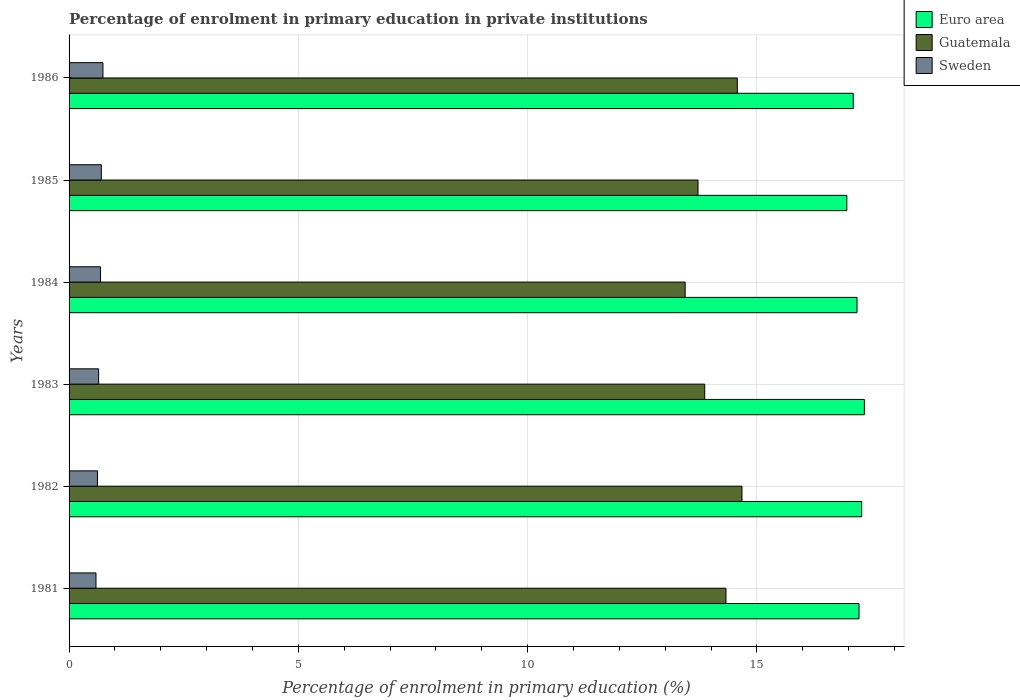How many different coloured bars are there?
Ensure brevity in your answer.  3. How many bars are there on the 2nd tick from the bottom?
Make the answer very short. 3. In how many cases, is the number of bars for a given year not equal to the number of legend labels?
Provide a succinct answer. 0. What is the percentage of enrolment in primary education in Euro area in 1986?
Your answer should be compact. 17.1. Across all years, what is the maximum percentage of enrolment in primary education in Euro area?
Offer a terse response. 17.34. Across all years, what is the minimum percentage of enrolment in primary education in Euro area?
Your answer should be very brief. 16.96. What is the total percentage of enrolment in primary education in Sweden in the graph?
Offer a very short reply. 3.98. What is the difference between the percentage of enrolment in primary education in Guatemala in 1981 and that in 1984?
Your answer should be compact. 0.89. What is the difference between the percentage of enrolment in primary education in Guatemala in 1985 and the percentage of enrolment in primary education in Sweden in 1986?
Provide a succinct answer. 12.98. What is the average percentage of enrolment in primary education in Sweden per year?
Your answer should be very brief. 0.66. In the year 1982, what is the difference between the percentage of enrolment in primary education in Euro area and percentage of enrolment in primary education in Sweden?
Offer a very short reply. 16.66. In how many years, is the percentage of enrolment in primary education in Guatemala greater than 5 %?
Keep it short and to the point. 6. What is the ratio of the percentage of enrolment in primary education in Euro area in 1982 to that in 1984?
Your answer should be compact. 1.01. Is the difference between the percentage of enrolment in primary education in Euro area in 1981 and 1986 greater than the difference between the percentage of enrolment in primary education in Sweden in 1981 and 1986?
Provide a short and direct response. Yes. What is the difference between the highest and the second highest percentage of enrolment in primary education in Sweden?
Give a very brief answer. 0.04. What is the difference between the highest and the lowest percentage of enrolment in primary education in Sweden?
Make the answer very short. 0.15. Is the sum of the percentage of enrolment in primary education in Euro area in 1983 and 1984 greater than the maximum percentage of enrolment in primary education in Sweden across all years?
Your response must be concise. Yes. What does the 3rd bar from the top in 1982 represents?
Your response must be concise. Euro area. What does the 2nd bar from the bottom in 1981 represents?
Give a very brief answer. Guatemala. Is it the case that in every year, the sum of the percentage of enrolment in primary education in Euro area and percentage of enrolment in primary education in Sweden is greater than the percentage of enrolment in primary education in Guatemala?
Give a very brief answer. Yes. How many bars are there?
Your answer should be very brief. 18. How many years are there in the graph?
Your answer should be very brief. 6. Does the graph contain any zero values?
Give a very brief answer. No. Does the graph contain grids?
Provide a short and direct response. Yes. How many legend labels are there?
Your answer should be very brief. 3. How are the legend labels stacked?
Keep it short and to the point. Vertical. What is the title of the graph?
Ensure brevity in your answer.  Percentage of enrolment in primary education in private institutions. What is the label or title of the X-axis?
Ensure brevity in your answer.  Percentage of enrolment in primary education (%). What is the label or title of the Y-axis?
Your answer should be very brief. Years. What is the Percentage of enrolment in primary education (%) in Euro area in 1981?
Make the answer very short. 17.22. What is the Percentage of enrolment in primary education (%) in Guatemala in 1981?
Your answer should be very brief. 14.32. What is the Percentage of enrolment in primary education (%) of Sweden in 1981?
Ensure brevity in your answer.  0.59. What is the Percentage of enrolment in primary education (%) in Euro area in 1982?
Give a very brief answer. 17.28. What is the Percentage of enrolment in primary education (%) in Guatemala in 1982?
Provide a short and direct response. 14.67. What is the Percentage of enrolment in primary education (%) of Sweden in 1982?
Offer a very short reply. 0.62. What is the Percentage of enrolment in primary education (%) of Euro area in 1983?
Your answer should be compact. 17.34. What is the Percentage of enrolment in primary education (%) of Guatemala in 1983?
Offer a very short reply. 13.86. What is the Percentage of enrolment in primary education (%) in Sweden in 1983?
Offer a very short reply. 0.64. What is the Percentage of enrolment in primary education (%) in Euro area in 1984?
Provide a short and direct response. 17.18. What is the Percentage of enrolment in primary education (%) of Guatemala in 1984?
Offer a very short reply. 13.43. What is the Percentage of enrolment in primary education (%) of Sweden in 1984?
Provide a short and direct response. 0.69. What is the Percentage of enrolment in primary education (%) in Euro area in 1985?
Keep it short and to the point. 16.96. What is the Percentage of enrolment in primary education (%) of Guatemala in 1985?
Provide a succinct answer. 13.71. What is the Percentage of enrolment in primary education (%) of Sweden in 1985?
Your response must be concise. 0.7. What is the Percentage of enrolment in primary education (%) of Euro area in 1986?
Offer a terse response. 17.1. What is the Percentage of enrolment in primary education (%) in Guatemala in 1986?
Offer a very short reply. 14.57. What is the Percentage of enrolment in primary education (%) of Sweden in 1986?
Ensure brevity in your answer.  0.74. Across all years, what is the maximum Percentage of enrolment in primary education (%) of Euro area?
Your answer should be very brief. 17.34. Across all years, what is the maximum Percentage of enrolment in primary education (%) in Guatemala?
Provide a succinct answer. 14.67. Across all years, what is the maximum Percentage of enrolment in primary education (%) in Sweden?
Your answer should be very brief. 0.74. Across all years, what is the minimum Percentage of enrolment in primary education (%) of Euro area?
Offer a terse response. 16.96. Across all years, what is the minimum Percentage of enrolment in primary education (%) in Guatemala?
Give a very brief answer. 13.43. Across all years, what is the minimum Percentage of enrolment in primary education (%) in Sweden?
Provide a succinct answer. 0.59. What is the total Percentage of enrolment in primary education (%) of Euro area in the graph?
Your response must be concise. 103.09. What is the total Percentage of enrolment in primary education (%) of Guatemala in the graph?
Your answer should be compact. 84.58. What is the total Percentage of enrolment in primary education (%) of Sweden in the graph?
Give a very brief answer. 3.98. What is the difference between the Percentage of enrolment in primary education (%) in Euro area in 1981 and that in 1982?
Make the answer very short. -0.06. What is the difference between the Percentage of enrolment in primary education (%) of Guatemala in 1981 and that in 1982?
Your response must be concise. -0.35. What is the difference between the Percentage of enrolment in primary education (%) in Sweden in 1981 and that in 1982?
Provide a succinct answer. -0.03. What is the difference between the Percentage of enrolment in primary education (%) of Euro area in 1981 and that in 1983?
Give a very brief answer. -0.12. What is the difference between the Percentage of enrolment in primary education (%) of Guatemala in 1981 and that in 1983?
Provide a succinct answer. 0.46. What is the difference between the Percentage of enrolment in primary education (%) of Sweden in 1981 and that in 1983?
Your answer should be compact. -0.06. What is the difference between the Percentage of enrolment in primary education (%) in Euro area in 1981 and that in 1984?
Ensure brevity in your answer.  0.04. What is the difference between the Percentage of enrolment in primary education (%) in Guatemala in 1981 and that in 1984?
Offer a very short reply. 0.89. What is the difference between the Percentage of enrolment in primary education (%) of Sweden in 1981 and that in 1984?
Your answer should be very brief. -0.1. What is the difference between the Percentage of enrolment in primary education (%) of Euro area in 1981 and that in 1985?
Ensure brevity in your answer.  0.27. What is the difference between the Percentage of enrolment in primary education (%) of Guatemala in 1981 and that in 1985?
Your response must be concise. 0.61. What is the difference between the Percentage of enrolment in primary education (%) of Sweden in 1981 and that in 1985?
Give a very brief answer. -0.12. What is the difference between the Percentage of enrolment in primary education (%) in Euro area in 1981 and that in 1986?
Make the answer very short. 0.13. What is the difference between the Percentage of enrolment in primary education (%) of Guatemala in 1981 and that in 1986?
Keep it short and to the point. -0.25. What is the difference between the Percentage of enrolment in primary education (%) of Sweden in 1981 and that in 1986?
Your response must be concise. -0.15. What is the difference between the Percentage of enrolment in primary education (%) of Euro area in 1982 and that in 1983?
Provide a succinct answer. -0.06. What is the difference between the Percentage of enrolment in primary education (%) in Guatemala in 1982 and that in 1983?
Offer a terse response. 0.81. What is the difference between the Percentage of enrolment in primary education (%) in Sweden in 1982 and that in 1983?
Give a very brief answer. -0.03. What is the difference between the Percentage of enrolment in primary education (%) in Euro area in 1982 and that in 1984?
Make the answer very short. 0.1. What is the difference between the Percentage of enrolment in primary education (%) in Guatemala in 1982 and that in 1984?
Your answer should be compact. 1.24. What is the difference between the Percentage of enrolment in primary education (%) in Sweden in 1982 and that in 1984?
Give a very brief answer. -0.07. What is the difference between the Percentage of enrolment in primary education (%) in Euro area in 1982 and that in 1985?
Provide a succinct answer. 0.32. What is the difference between the Percentage of enrolment in primary education (%) in Guatemala in 1982 and that in 1985?
Offer a terse response. 0.96. What is the difference between the Percentage of enrolment in primary education (%) of Sweden in 1982 and that in 1985?
Your response must be concise. -0.08. What is the difference between the Percentage of enrolment in primary education (%) in Euro area in 1982 and that in 1986?
Offer a terse response. 0.18. What is the difference between the Percentage of enrolment in primary education (%) of Guatemala in 1982 and that in 1986?
Offer a very short reply. 0.1. What is the difference between the Percentage of enrolment in primary education (%) in Sweden in 1982 and that in 1986?
Offer a terse response. -0.12. What is the difference between the Percentage of enrolment in primary education (%) of Euro area in 1983 and that in 1984?
Make the answer very short. 0.16. What is the difference between the Percentage of enrolment in primary education (%) of Guatemala in 1983 and that in 1984?
Offer a very short reply. 0.43. What is the difference between the Percentage of enrolment in primary education (%) in Sweden in 1983 and that in 1984?
Your response must be concise. -0.04. What is the difference between the Percentage of enrolment in primary education (%) of Euro area in 1983 and that in 1985?
Offer a very short reply. 0.38. What is the difference between the Percentage of enrolment in primary education (%) of Guatemala in 1983 and that in 1985?
Offer a very short reply. 0.15. What is the difference between the Percentage of enrolment in primary education (%) in Sweden in 1983 and that in 1985?
Your answer should be compact. -0.06. What is the difference between the Percentage of enrolment in primary education (%) in Euro area in 1983 and that in 1986?
Provide a short and direct response. 0.24. What is the difference between the Percentage of enrolment in primary education (%) in Guatemala in 1983 and that in 1986?
Ensure brevity in your answer.  -0.71. What is the difference between the Percentage of enrolment in primary education (%) in Sweden in 1983 and that in 1986?
Your response must be concise. -0.09. What is the difference between the Percentage of enrolment in primary education (%) of Euro area in 1984 and that in 1985?
Your response must be concise. 0.22. What is the difference between the Percentage of enrolment in primary education (%) of Guatemala in 1984 and that in 1985?
Offer a terse response. -0.28. What is the difference between the Percentage of enrolment in primary education (%) of Sweden in 1984 and that in 1985?
Keep it short and to the point. -0.02. What is the difference between the Percentage of enrolment in primary education (%) in Euro area in 1984 and that in 1986?
Ensure brevity in your answer.  0.08. What is the difference between the Percentage of enrolment in primary education (%) in Guatemala in 1984 and that in 1986?
Provide a short and direct response. -1.14. What is the difference between the Percentage of enrolment in primary education (%) in Sweden in 1984 and that in 1986?
Your answer should be compact. -0.05. What is the difference between the Percentage of enrolment in primary education (%) in Euro area in 1985 and that in 1986?
Offer a terse response. -0.14. What is the difference between the Percentage of enrolment in primary education (%) in Guatemala in 1985 and that in 1986?
Your response must be concise. -0.86. What is the difference between the Percentage of enrolment in primary education (%) in Sweden in 1985 and that in 1986?
Give a very brief answer. -0.04. What is the difference between the Percentage of enrolment in primary education (%) in Euro area in 1981 and the Percentage of enrolment in primary education (%) in Guatemala in 1982?
Your response must be concise. 2.55. What is the difference between the Percentage of enrolment in primary education (%) of Euro area in 1981 and the Percentage of enrolment in primary education (%) of Sweden in 1982?
Offer a terse response. 16.61. What is the difference between the Percentage of enrolment in primary education (%) in Guatemala in 1981 and the Percentage of enrolment in primary education (%) in Sweden in 1982?
Keep it short and to the point. 13.7. What is the difference between the Percentage of enrolment in primary education (%) in Euro area in 1981 and the Percentage of enrolment in primary education (%) in Guatemala in 1983?
Make the answer very short. 3.36. What is the difference between the Percentage of enrolment in primary education (%) in Euro area in 1981 and the Percentage of enrolment in primary education (%) in Sweden in 1983?
Your answer should be very brief. 16.58. What is the difference between the Percentage of enrolment in primary education (%) in Guatemala in 1981 and the Percentage of enrolment in primary education (%) in Sweden in 1983?
Make the answer very short. 13.68. What is the difference between the Percentage of enrolment in primary education (%) in Euro area in 1981 and the Percentage of enrolment in primary education (%) in Guatemala in 1984?
Make the answer very short. 3.79. What is the difference between the Percentage of enrolment in primary education (%) in Euro area in 1981 and the Percentage of enrolment in primary education (%) in Sweden in 1984?
Your response must be concise. 16.54. What is the difference between the Percentage of enrolment in primary education (%) in Guatemala in 1981 and the Percentage of enrolment in primary education (%) in Sweden in 1984?
Your answer should be compact. 13.64. What is the difference between the Percentage of enrolment in primary education (%) of Euro area in 1981 and the Percentage of enrolment in primary education (%) of Guatemala in 1985?
Your answer should be compact. 3.51. What is the difference between the Percentage of enrolment in primary education (%) in Euro area in 1981 and the Percentage of enrolment in primary education (%) in Sweden in 1985?
Your response must be concise. 16.52. What is the difference between the Percentage of enrolment in primary education (%) in Guatemala in 1981 and the Percentage of enrolment in primary education (%) in Sweden in 1985?
Make the answer very short. 13.62. What is the difference between the Percentage of enrolment in primary education (%) of Euro area in 1981 and the Percentage of enrolment in primary education (%) of Guatemala in 1986?
Your answer should be very brief. 2.65. What is the difference between the Percentage of enrolment in primary education (%) of Euro area in 1981 and the Percentage of enrolment in primary education (%) of Sweden in 1986?
Give a very brief answer. 16.49. What is the difference between the Percentage of enrolment in primary education (%) of Guatemala in 1981 and the Percentage of enrolment in primary education (%) of Sweden in 1986?
Provide a succinct answer. 13.59. What is the difference between the Percentage of enrolment in primary education (%) of Euro area in 1982 and the Percentage of enrolment in primary education (%) of Guatemala in 1983?
Offer a terse response. 3.42. What is the difference between the Percentage of enrolment in primary education (%) of Euro area in 1982 and the Percentage of enrolment in primary education (%) of Sweden in 1983?
Keep it short and to the point. 16.64. What is the difference between the Percentage of enrolment in primary education (%) in Guatemala in 1982 and the Percentage of enrolment in primary education (%) in Sweden in 1983?
Keep it short and to the point. 14.03. What is the difference between the Percentage of enrolment in primary education (%) in Euro area in 1982 and the Percentage of enrolment in primary education (%) in Guatemala in 1984?
Your answer should be very brief. 3.85. What is the difference between the Percentage of enrolment in primary education (%) of Euro area in 1982 and the Percentage of enrolment in primary education (%) of Sweden in 1984?
Your answer should be very brief. 16.6. What is the difference between the Percentage of enrolment in primary education (%) in Guatemala in 1982 and the Percentage of enrolment in primary education (%) in Sweden in 1984?
Make the answer very short. 13.99. What is the difference between the Percentage of enrolment in primary education (%) in Euro area in 1982 and the Percentage of enrolment in primary education (%) in Guatemala in 1985?
Your response must be concise. 3.57. What is the difference between the Percentage of enrolment in primary education (%) of Euro area in 1982 and the Percentage of enrolment in primary education (%) of Sweden in 1985?
Give a very brief answer. 16.58. What is the difference between the Percentage of enrolment in primary education (%) in Guatemala in 1982 and the Percentage of enrolment in primary education (%) in Sweden in 1985?
Offer a very short reply. 13.97. What is the difference between the Percentage of enrolment in primary education (%) in Euro area in 1982 and the Percentage of enrolment in primary education (%) in Guatemala in 1986?
Ensure brevity in your answer.  2.71. What is the difference between the Percentage of enrolment in primary education (%) of Euro area in 1982 and the Percentage of enrolment in primary education (%) of Sweden in 1986?
Provide a succinct answer. 16.54. What is the difference between the Percentage of enrolment in primary education (%) in Guatemala in 1982 and the Percentage of enrolment in primary education (%) in Sweden in 1986?
Offer a terse response. 13.93. What is the difference between the Percentage of enrolment in primary education (%) of Euro area in 1983 and the Percentage of enrolment in primary education (%) of Guatemala in 1984?
Make the answer very short. 3.91. What is the difference between the Percentage of enrolment in primary education (%) of Euro area in 1983 and the Percentage of enrolment in primary education (%) of Sweden in 1984?
Ensure brevity in your answer.  16.66. What is the difference between the Percentage of enrolment in primary education (%) of Guatemala in 1983 and the Percentage of enrolment in primary education (%) of Sweden in 1984?
Offer a terse response. 13.17. What is the difference between the Percentage of enrolment in primary education (%) of Euro area in 1983 and the Percentage of enrolment in primary education (%) of Guatemala in 1985?
Your answer should be compact. 3.63. What is the difference between the Percentage of enrolment in primary education (%) in Euro area in 1983 and the Percentage of enrolment in primary education (%) in Sweden in 1985?
Keep it short and to the point. 16.64. What is the difference between the Percentage of enrolment in primary education (%) of Guatemala in 1983 and the Percentage of enrolment in primary education (%) of Sweden in 1985?
Provide a succinct answer. 13.16. What is the difference between the Percentage of enrolment in primary education (%) in Euro area in 1983 and the Percentage of enrolment in primary education (%) in Guatemala in 1986?
Provide a succinct answer. 2.77. What is the difference between the Percentage of enrolment in primary education (%) of Euro area in 1983 and the Percentage of enrolment in primary education (%) of Sweden in 1986?
Make the answer very short. 16.6. What is the difference between the Percentage of enrolment in primary education (%) in Guatemala in 1983 and the Percentage of enrolment in primary education (%) in Sweden in 1986?
Make the answer very short. 13.12. What is the difference between the Percentage of enrolment in primary education (%) in Euro area in 1984 and the Percentage of enrolment in primary education (%) in Guatemala in 1985?
Keep it short and to the point. 3.47. What is the difference between the Percentage of enrolment in primary education (%) of Euro area in 1984 and the Percentage of enrolment in primary education (%) of Sweden in 1985?
Offer a terse response. 16.48. What is the difference between the Percentage of enrolment in primary education (%) of Guatemala in 1984 and the Percentage of enrolment in primary education (%) of Sweden in 1985?
Offer a terse response. 12.73. What is the difference between the Percentage of enrolment in primary education (%) in Euro area in 1984 and the Percentage of enrolment in primary education (%) in Guatemala in 1986?
Offer a very short reply. 2.61. What is the difference between the Percentage of enrolment in primary education (%) of Euro area in 1984 and the Percentage of enrolment in primary education (%) of Sweden in 1986?
Provide a succinct answer. 16.44. What is the difference between the Percentage of enrolment in primary education (%) of Guatemala in 1984 and the Percentage of enrolment in primary education (%) of Sweden in 1986?
Provide a succinct answer. 12.7. What is the difference between the Percentage of enrolment in primary education (%) in Euro area in 1985 and the Percentage of enrolment in primary education (%) in Guatemala in 1986?
Ensure brevity in your answer.  2.39. What is the difference between the Percentage of enrolment in primary education (%) of Euro area in 1985 and the Percentage of enrolment in primary education (%) of Sweden in 1986?
Provide a short and direct response. 16.22. What is the difference between the Percentage of enrolment in primary education (%) in Guatemala in 1985 and the Percentage of enrolment in primary education (%) in Sweden in 1986?
Your response must be concise. 12.98. What is the average Percentage of enrolment in primary education (%) in Euro area per year?
Provide a short and direct response. 17.18. What is the average Percentage of enrolment in primary education (%) of Guatemala per year?
Ensure brevity in your answer.  14.1. What is the average Percentage of enrolment in primary education (%) in Sweden per year?
Provide a short and direct response. 0.66. In the year 1981, what is the difference between the Percentage of enrolment in primary education (%) of Euro area and Percentage of enrolment in primary education (%) of Guatemala?
Make the answer very short. 2.9. In the year 1981, what is the difference between the Percentage of enrolment in primary education (%) of Euro area and Percentage of enrolment in primary education (%) of Sweden?
Provide a succinct answer. 16.64. In the year 1981, what is the difference between the Percentage of enrolment in primary education (%) of Guatemala and Percentage of enrolment in primary education (%) of Sweden?
Give a very brief answer. 13.74. In the year 1982, what is the difference between the Percentage of enrolment in primary education (%) in Euro area and Percentage of enrolment in primary education (%) in Guatemala?
Ensure brevity in your answer.  2.61. In the year 1982, what is the difference between the Percentage of enrolment in primary education (%) in Euro area and Percentage of enrolment in primary education (%) in Sweden?
Keep it short and to the point. 16.66. In the year 1982, what is the difference between the Percentage of enrolment in primary education (%) of Guatemala and Percentage of enrolment in primary education (%) of Sweden?
Keep it short and to the point. 14.05. In the year 1983, what is the difference between the Percentage of enrolment in primary education (%) of Euro area and Percentage of enrolment in primary education (%) of Guatemala?
Offer a very short reply. 3.48. In the year 1983, what is the difference between the Percentage of enrolment in primary education (%) in Euro area and Percentage of enrolment in primary education (%) in Sweden?
Provide a short and direct response. 16.7. In the year 1983, what is the difference between the Percentage of enrolment in primary education (%) in Guatemala and Percentage of enrolment in primary education (%) in Sweden?
Offer a very short reply. 13.22. In the year 1984, what is the difference between the Percentage of enrolment in primary education (%) of Euro area and Percentage of enrolment in primary education (%) of Guatemala?
Your answer should be very brief. 3.75. In the year 1984, what is the difference between the Percentage of enrolment in primary education (%) of Euro area and Percentage of enrolment in primary education (%) of Sweden?
Offer a very short reply. 16.5. In the year 1984, what is the difference between the Percentage of enrolment in primary education (%) in Guatemala and Percentage of enrolment in primary education (%) in Sweden?
Give a very brief answer. 12.75. In the year 1985, what is the difference between the Percentage of enrolment in primary education (%) of Euro area and Percentage of enrolment in primary education (%) of Guatemala?
Keep it short and to the point. 3.24. In the year 1985, what is the difference between the Percentage of enrolment in primary education (%) in Euro area and Percentage of enrolment in primary education (%) in Sweden?
Your answer should be very brief. 16.26. In the year 1985, what is the difference between the Percentage of enrolment in primary education (%) of Guatemala and Percentage of enrolment in primary education (%) of Sweden?
Your answer should be compact. 13.01. In the year 1986, what is the difference between the Percentage of enrolment in primary education (%) of Euro area and Percentage of enrolment in primary education (%) of Guatemala?
Your answer should be compact. 2.53. In the year 1986, what is the difference between the Percentage of enrolment in primary education (%) in Euro area and Percentage of enrolment in primary education (%) in Sweden?
Provide a succinct answer. 16.36. In the year 1986, what is the difference between the Percentage of enrolment in primary education (%) of Guatemala and Percentage of enrolment in primary education (%) of Sweden?
Your answer should be very brief. 13.83. What is the ratio of the Percentage of enrolment in primary education (%) of Guatemala in 1981 to that in 1982?
Keep it short and to the point. 0.98. What is the ratio of the Percentage of enrolment in primary education (%) of Sweden in 1981 to that in 1982?
Your answer should be very brief. 0.95. What is the ratio of the Percentage of enrolment in primary education (%) of Euro area in 1981 to that in 1983?
Give a very brief answer. 0.99. What is the ratio of the Percentage of enrolment in primary education (%) in Guatemala in 1981 to that in 1983?
Ensure brevity in your answer.  1.03. What is the ratio of the Percentage of enrolment in primary education (%) of Sweden in 1981 to that in 1983?
Your answer should be very brief. 0.91. What is the ratio of the Percentage of enrolment in primary education (%) of Euro area in 1981 to that in 1984?
Provide a succinct answer. 1. What is the ratio of the Percentage of enrolment in primary education (%) of Guatemala in 1981 to that in 1984?
Your answer should be compact. 1.07. What is the ratio of the Percentage of enrolment in primary education (%) in Sweden in 1981 to that in 1984?
Your answer should be compact. 0.86. What is the ratio of the Percentage of enrolment in primary education (%) in Euro area in 1981 to that in 1985?
Your answer should be very brief. 1.02. What is the ratio of the Percentage of enrolment in primary education (%) in Guatemala in 1981 to that in 1985?
Ensure brevity in your answer.  1.04. What is the ratio of the Percentage of enrolment in primary education (%) of Sweden in 1981 to that in 1985?
Provide a short and direct response. 0.83. What is the ratio of the Percentage of enrolment in primary education (%) of Euro area in 1981 to that in 1986?
Your response must be concise. 1.01. What is the ratio of the Percentage of enrolment in primary education (%) in Sweden in 1981 to that in 1986?
Offer a terse response. 0.79. What is the ratio of the Percentage of enrolment in primary education (%) in Guatemala in 1982 to that in 1983?
Make the answer very short. 1.06. What is the ratio of the Percentage of enrolment in primary education (%) of Sweden in 1982 to that in 1983?
Ensure brevity in your answer.  0.96. What is the ratio of the Percentage of enrolment in primary education (%) in Euro area in 1982 to that in 1984?
Make the answer very short. 1.01. What is the ratio of the Percentage of enrolment in primary education (%) of Guatemala in 1982 to that in 1984?
Provide a short and direct response. 1.09. What is the ratio of the Percentage of enrolment in primary education (%) in Sweden in 1982 to that in 1984?
Ensure brevity in your answer.  0.9. What is the ratio of the Percentage of enrolment in primary education (%) in Euro area in 1982 to that in 1985?
Your answer should be compact. 1.02. What is the ratio of the Percentage of enrolment in primary education (%) of Guatemala in 1982 to that in 1985?
Provide a succinct answer. 1.07. What is the ratio of the Percentage of enrolment in primary education (%) in Sweden in 1982 to that in 1985?
Provide a succinct answer. 0.88. What is the ratio of the Percentage of enrolment in primary education (%) of Euro area in 1982 to that in 1986?
Make the answer very short. 1.01. What is the ratio of the Percentage of enrolment in primary education (%) of Sweden in 1982 to that in 1986?
Make the answer very short. 0.84. What is the ratio of the Percentage of enrolment in primary education (%) in Euro area in 1983 to that in 1984?
Keep it short and to the point. 1.01. What is the ratio of the Percentage of enrolment in primary education (%) of Guatemala in 1983 to that in 1984?
Give a very brief answer. 1.03. What is the ratio of the Percentage of enrolment in primary education (%) in Sweden in 1983 to that in 1984?
Your response must be concise. 0.94. What is the ratio of the Percentage of enrolment in primary education (%) in Euro area in 1983 to that in 1985?
Provide a succinct answer. 1.02. What is the ratio of the Percentage of enrolment in primary education (%) in Guatemala in 1983 to that in 1985?
Your answer should be compact. 1.01. What is the ratio of the Percentage of enrolment in primary education (%) of Sweden in 1983 to that in 1985?
Your answer should be compact. 0.92. What is the ratio of the Percentage of enrolment in primary education (%) in Euro area in 1983 to that in 1986?
Your answer should be compact. 1.01. What is the ratio of the Percentage of enrolment in primary education (%) of Guatemala in 1983 to that in 1986?
Ensure brevity in your answer.  0.95. What is the ratio of the Percentage of enrolment in primary education (%) of Sweden in 1983 to that in 1986?
Ensure brevity in your answer.  0.87. What is the ratio of the Percentage of enrolment in primary education (%) of Euro area in 1984 to that in 1985?
Provide a succinct answer. 1.01. What is the ratio of the Percentage of enrolment in primary education (%) in Guatemala in 1984 to that in 1985?
Offer a very short reply. 0.98. What is the ratio of the Percentage of enrolment in primary education (%) of Sweden in 1984 to that in 1985?
Ensure brevity in your answer.  0.98. What is the ratio of the Percentage of enrolment in primary education (%) of Guatemala in 1984 to that in 1986?
Your answer should be very brief. 0.92. What is the ratio of the Percentage of enrolment in primary education (%) in Sweden in 1984 to that in 1986?
Offer a very short reply. 0.93. What is the ratio of the Percentage of enrolment in primary education (%) in Guatemala in 1985 to that in 1986?
Your answer should be very brief. 0.94. What is the ratio of the Percentage of enrolment in primary education (%) of Sweden in 1985 to that in 1986?
Make the answer very short. 0.95. What is the difference between the highest and the second highest Percentage of enrolment in primary education (%) of Euro area?
Keep it short and to the point. 0.06. What is the difference between the highest and the second highest Percentage of enrolment in primary education (%) in Guatemala?
Ensure brevity in your answer.  0.1. What is the difference between the highest and the second highest Percentage of enrolment in primary education (%) in Sweden?
Your answer should be very brief. 0.04. What is the difference between the highest and the lowest Percentage of enrolment in primary education (%) of Euro area?
Offer a terse response. 0.38. What is the difference between the highest and the lowest Percentage of enrolment in primary education (%) of Guatemala?
Your answer should be compact. 1.24. What is the difference between the highest and the lowest Percentage of enrolment in primary education (%) of Sweden?
Provide a succinct answer. 0.15. 